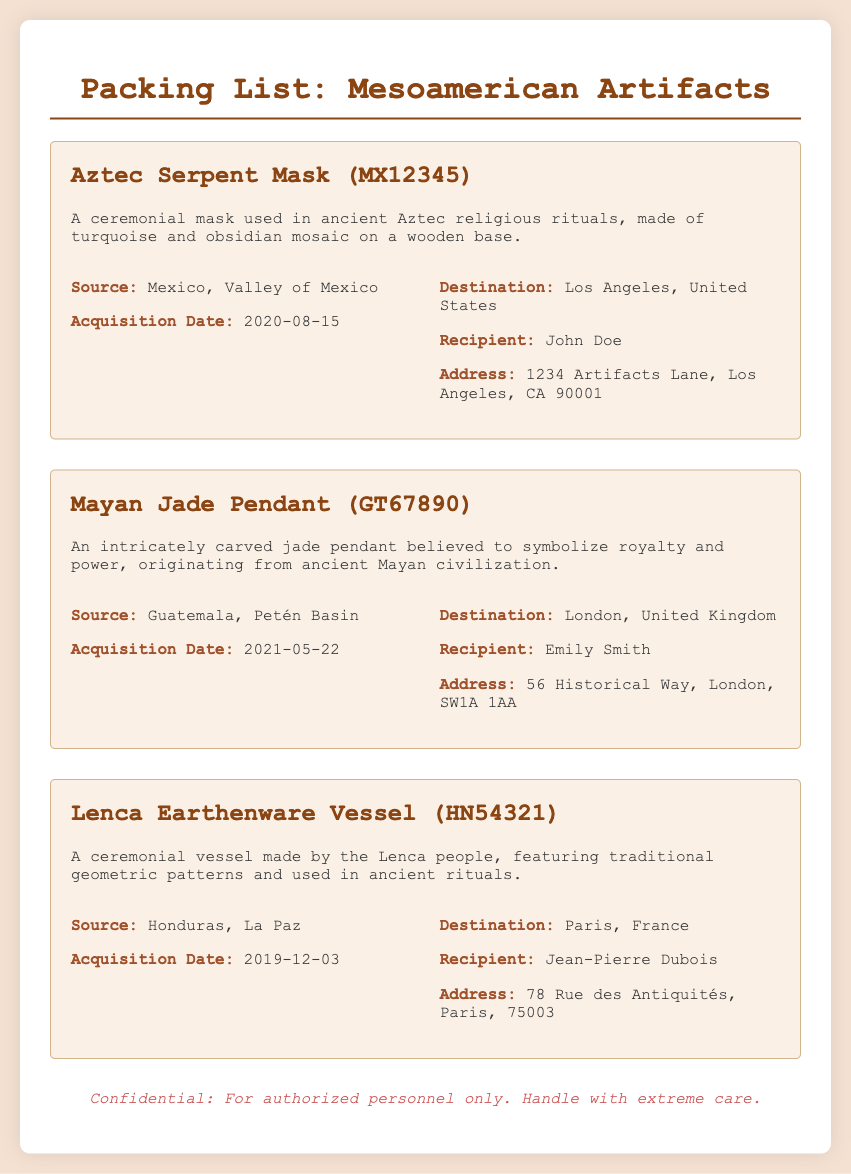What is the title of the document? The title is provided at the top of the document, indicating what the document pertains to.
Answer: Packing List: Mesoamerican Artifacts What is the source of the Aztec Serpent Mask? The source details are outlined under the artifact's description, specifying where it originated.
Answer: Mexico, Valley of Mexico Who is the recipient of the Mayan Jade Pendant? The recipient's name is mentioned in the destination details for the artifact.
Answer: Emily Smith When was the Lenca Earthenware Vessel acquired? The acquisition date for this artifact is provided under its source information.
Answer: 2019-12-03 What is the destination for the Aztec Serpent Mask? The destination information indicates where the artifact is being sent.
Answer: Los Angeles, United States Which artifact is associated with the acquisition date 2021-05-22? This date corresponds to an acquisition date listed for an artifact, leading to its identification.
Answer: Mayan Jade Pendant How many artifacts are listed in the document? The count is determined by identifying each distinct artifact outlined within the document.
Answer: 3 What country does the Lenca Earthenware Vessel come from? The origin of this artifact is specified in the source details presented in the document.
Answer: Honduras What is the address for the recipient of the Lenca Earthenware Vessel? The address is provided in the destination details for the respective artifact.
Answer: 78 Rue des Antiquités, Paris, 75003 